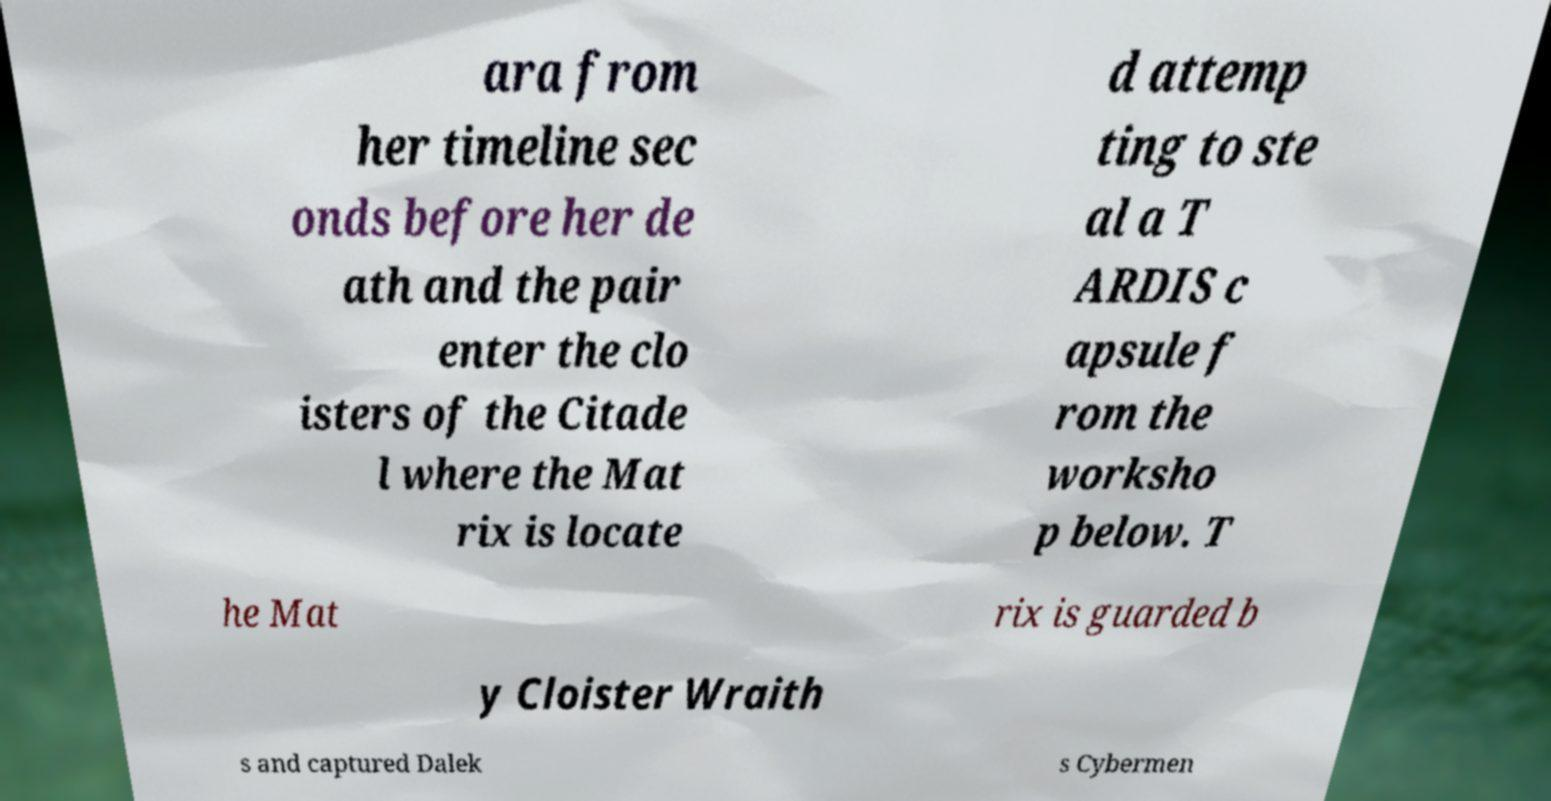There's text embedded in this image that I need extracted. Can you transcribe it verbatim? ara from her timeline sec onds before her de ath and the pair enter the clo isters of the Citade l where the Mat rix is locate d attemp ting to ste al a T ARDIS c apsule f rom the worksho p below. T he Mat rix is guarded b y Cloister Wraith s and captured Dalek s Cybermen 